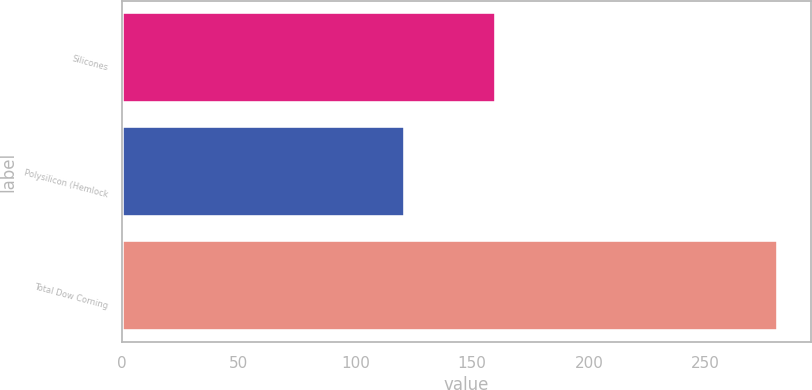Convert chart to OTSL. <chart><loc_0><loc_0><loc_500><loc_500><bar_chart><fcel>Silicones<fcel>Polysilicon (Hemlock<fcel>Total Dow Corning<nl><fcel>160<fcel>121<fcel>281<nl></chart> 